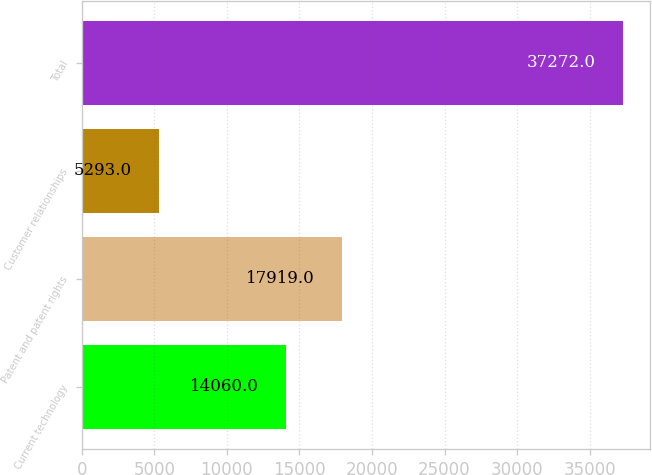<chart> <loc_0><loc_0><loc_500><loc_500><bar_chart><fcel>Current technology<fcel>Patent and patent rights<fcel>Customer relationships<fcel>Total<nl><fcel>14060<fcel>17919<fcel>5293<fcel>37272<nl></chart> 